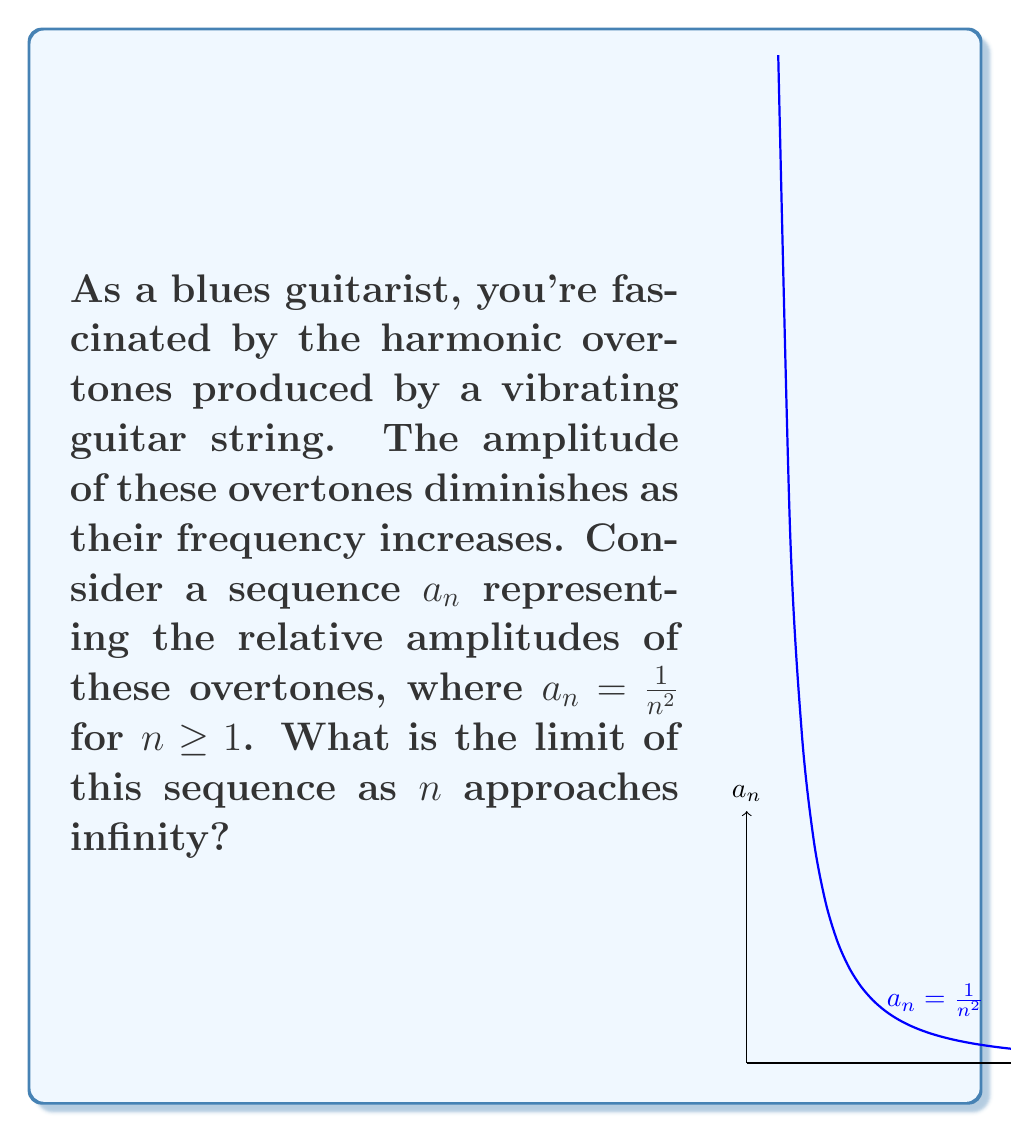Show me your answer to this math problem. Let's approach this step-by-step:

1) We're dealing with the sequence $a_n = \frac{1}{n^2}$ where $n \geq 1$.

2) To find the limit as $n$ approaches infinity, we need to evaluate:

   $$\lim_{n \to \infty} \frac{1}{n^2}$$

3) As $n$ gets larger, $n^2$ grows much faster than $n$. This means that $\frac{1}{n^2}$ will get smaller and smaller.

4) We can see this intuitively:
   - When $n = 1$, $a_1 = \frac{1}{1^2} = 1$
   - When $n = 10$, $a_{10} = \frac{1}{10^2} = 0.01$
   - When $n = 100$, $a_{100} = \frac{1}{100^2} = 0.0001$

5) As $n$ continues to grow, $\frac{1}{n^2}$ will get arbitrarily close to 0.

6) Mathematically, for any small positive number $\epsilon$, we can always find a large enough $N$ such that $\frac{1}{n^2} < \epsilon$ for all $n > N$.

7) This is the definition of the limit of a sequence being 0.

Therefore, the limit of the sequence as $n$ approaches infinity is 0.
Answer: $0$ 